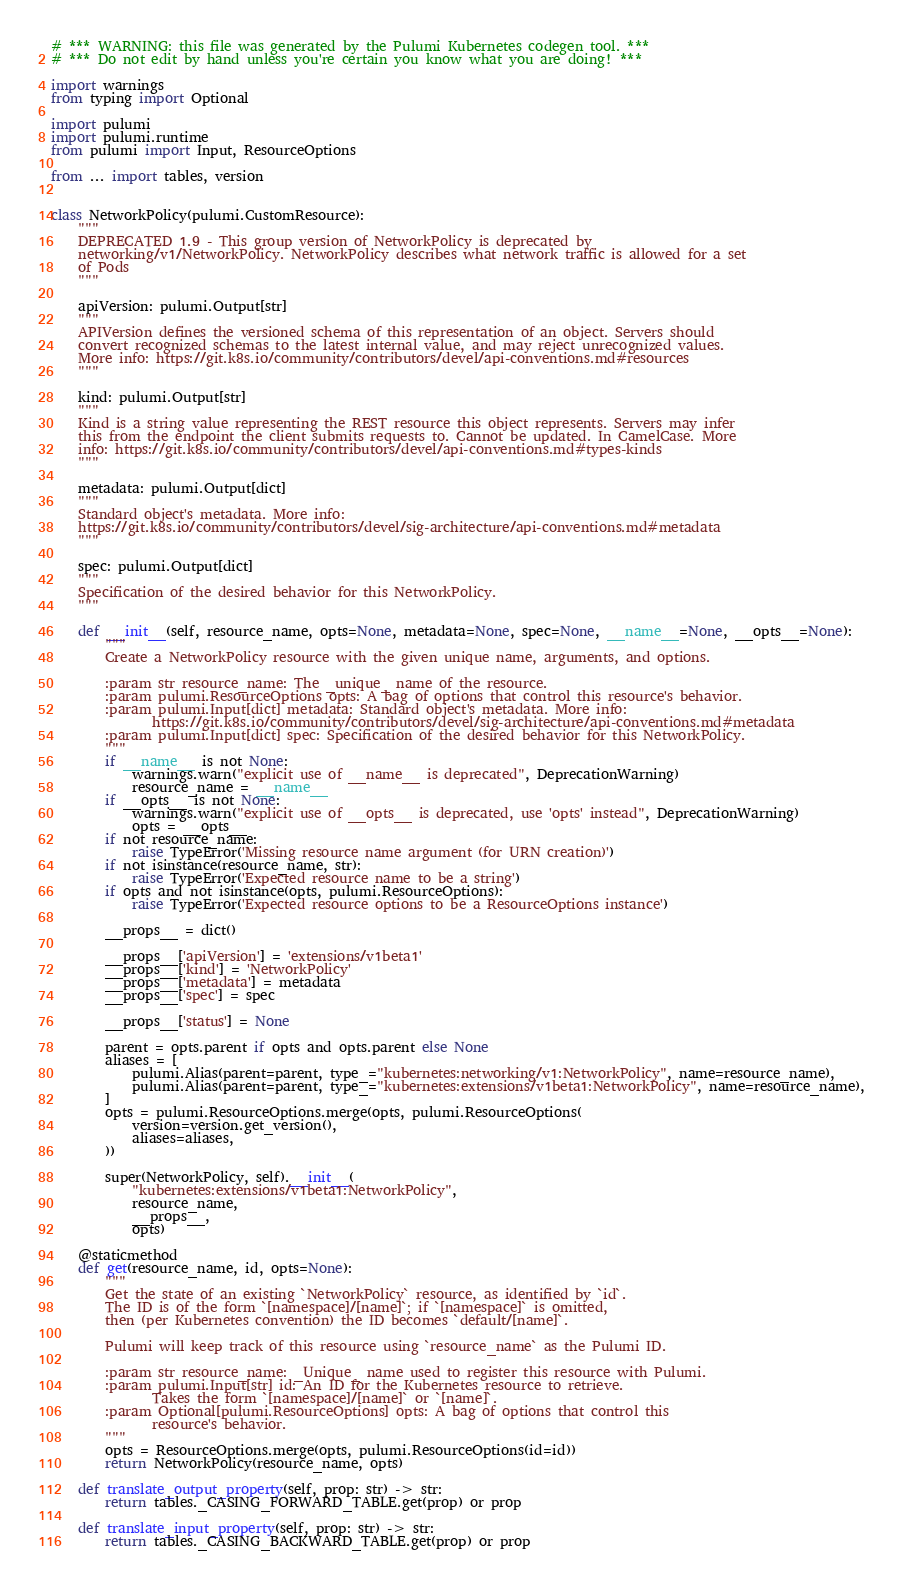<code> <loc_0><loc_0><loc_500><loc_500><_Python_># *** WARNING: this file was generated by the Pulumi Kubernetes codegen tool. ***
# *** Do not edit by hand unless you're certain you know what you are doing! ***

import warnings
from typing import Optional

import pulumi
import pulumi.runtime
from pulumi import Input, ResourceOptions

from ... import tables, version


class NetworkPolicy(pulumi.CustomResource):
    """
    DEPRECATED 1.9 - This group version of NetworkPolicy is deprecated by
    networking/v1/NetworkPolicy. NetworkPolicy describes what network traffic is allowed for a set
    of Pods
    """

    apiVersion: pulumi.Output[str]
    """
    APIVersion defines the versioned schema of this representation of an object. Servers should
    convert recognized schemas to the latest internal value, and may reject unrecognized values.
    More info: https://git.k8s.io/community/contributors/devel/api-conventions.md#resources
    """

    kind: pulumi.Output[str]
    """
    Kind is a string value representing the REST resource this object represents. Servers may infer
    this from the endpoint the client submits requests to. Cannot be updated. In CamelCase. More
    info: https://git.k8s.io/community/contributors/devel/api-conventions.md#types-kinds
    """

    metadata: pulumi.Output[dict]
    """
    Standard object's metadata. More info:
    https://git.k8s.io/community/contributors/devel/sig-architecture/api-conventions.md#metadata
    """

    spec: pulumi.Output[dict]
    """
    Specification of the desired behavior for this NetworkPolicy.
    """

    def __init__(self, resource_name, opts=None, metadata=None, spec=None, __name__=None, __opts__=None):
        """
        Create a NetworkPolicy resource with the given unique name, arguments, and options.

        :param str resource_name: The _unique_ name of the resource.
        :param pulumi.ResourceOptions opts: A bag of options that control this resource's behavior.
        :param pulumi.Input[dict] metadata: Standard object's metadata. More info:
               https://git.k8s.io/community/contributors/devel/sig-architecture/api-conventions.md#metadata
        :param pulumi.Input[dict] spec: Specification of the desired behavior for this NetworkPolicy.
        """
        if __name__ is not None:
            warnings.warn("explicit use of __name__ is deprecated", DeprecationWarning)
            resource_name = __name__
        if __opts__ is not None:
            warnings.warn("explicit use of __opts__ is deprecated, use 'opts' instead", DeprecationWarning)
            opts = __opts__
        if not resource_name:
            raise TypeError('Missing resource name argument (for URN creation)')
        if not isinstance(resource_name, str):
            raise TypeError('Expected resource name to be a string')
        if opts and not isinstance(opts, pulumi.ResourceOptions):
            raise TypeError('Expected resource options to be a ResourceOptions instance')

        __props__ = dict()

        __props__['apiVersion'] = 'extensions/v1beta1'
        __props__['kind'] = 'NetworkPolicy'
        __props__['metadata'] = metadata
        __props__['spec'] = spec

        __props__['status'] = None

        parent = opts.parent if opts and opts.parent else None
        aliases = [
            pulumi.Alias(parent=parent, type_="kubernetes:networking/v1:NetworkPolicy", name=resource_name),
            pulumi.Alias(parent=parent, type_="kubernetes:extensions/v1beta1:NetworkPolicy", name=resource_name),
        ]
        opts = pulumi.ResourceOptions.merge(opts, pulumi.ResourceOptions(
            version=version.get_version(),
            aliases=aliases,
        ))

        super(NetworkPolicy, self).__init__(
            "kubernetes:extensions/v1beta1:NetworkPolicy",
            resource_name,
            __props__,
            opts)

    @staticmethod
    def get(resource_name, id, opts=None):
        """
        Get the state of an existing `NetworkPolicy` resource, as identified by `id`.
        The ID is of the form `[namespace]/[name]`; if `[namespace]` is omitted,
        then (per Kubernetes convention) the ID becomes `default/[name]`.

        Pulumi will keep track of this resource using `resource_name` as the Pulumi ID.

        :param str resource_name: _Unique_ name used to register this resource with Pulumi.
        :param pulumi.Input[str] id: An ID for the Kubernetes resource to retrieve.
               Takes the form `[namespace]/[name]` or `[name]`.
        :param Optional[pulumi.ResourceOptions] opts: A bag of options that control this
               resource's behavior.
        """
        opts = ResourceOptions.merge(opts, pulumi.ResourceOptions(id=id))
        return NetworkPolicy(resource_name, opts)

    def translate_output_property(self, prop: str) -> str:
        return tables._CASING_FORWARD_TABLE.get(prop) or prop

    def translate_input_property(self, prop: str) -> str:
        return tables._CASING_BACKWARD_TABLE.get(prop) or prop
</code> 